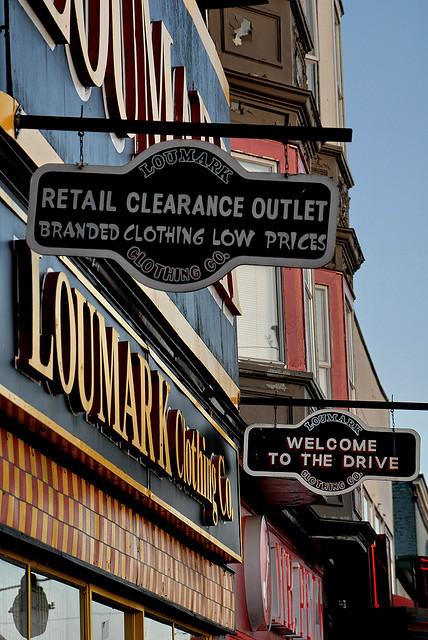Is this a restaurant?
Write a very short answer. No. What is written on the sign hanging from the side of the building?
Give a very brief answer. Welcome to drive. What do they sell at the outlet?
Answer briefly. Clothing. 